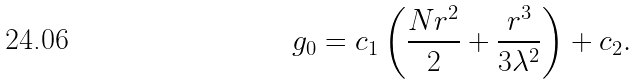<formula> <loc_0><loc_0><loc_500><loc_500>g _ { 0 } = c _ { 1 } \left ( \frac { N r ^ { 2 } } { 2 } + \frac { r ^ { 3 } } { 3 \lambda ^ { 2 } } \right ) + c _ { 2 } .</formula> 